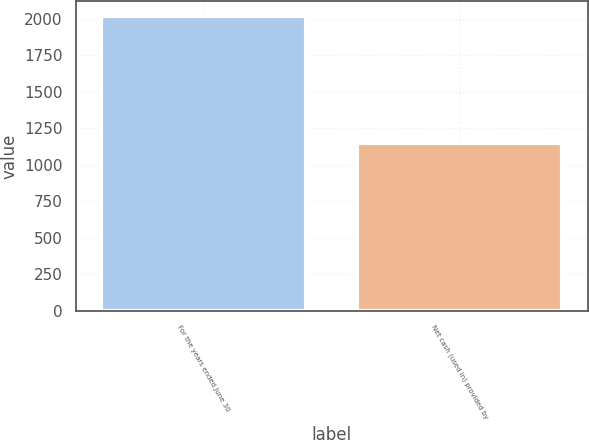Convert chart. <chart><loc_0><loc_0><loc_500><loc_500><bar_chart><fcel>For the years ended June 30<fcel>Net cash (used in) provided by<nl><fcel>2019<fcel>1153<nl></chart> 